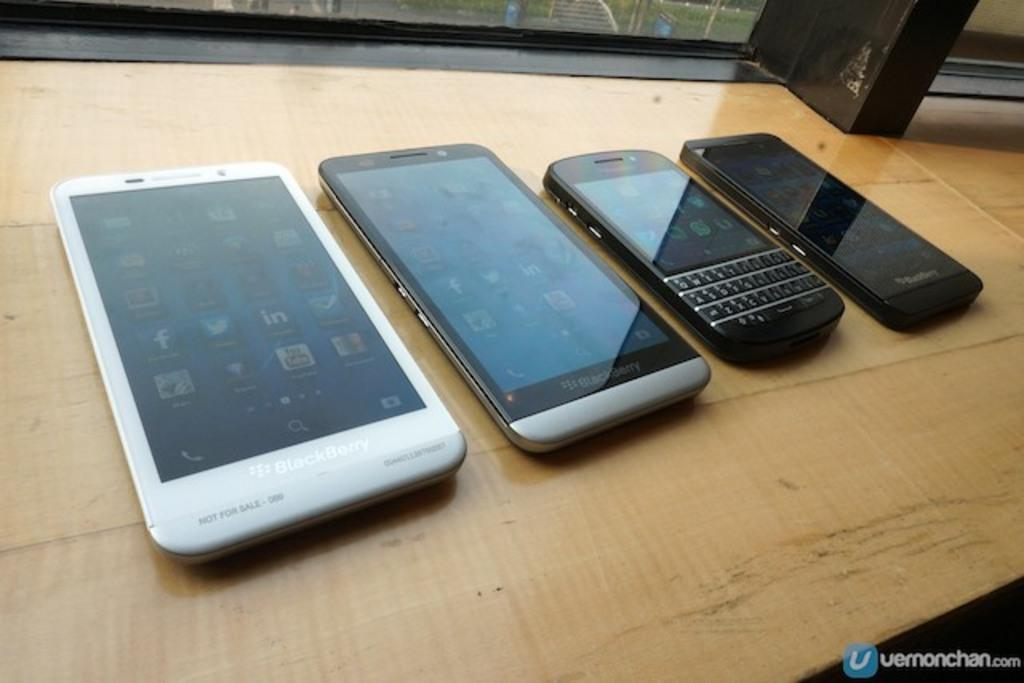How many mobile phones are visible on the table in the image? There are four mobile phones on the table in the image. What can be seen in the background of the image? There is a glass window in the background of the image. What type of paste is being used in the image? There is no paste present in the image. What process is being carried out in the image? The image does not depict any specific process; it simply shows four mobile phones on a table and a glass window in the background. 